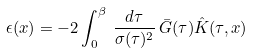<formula> <loc_0><loc_0><loc_500><loc_500>\epsilon ( x ) = - 2 \int _ { 0 } ^ { \beta } \, \frac { d \tau } { \sigma ( \tau ) ^ { 2 } } \, \bar { G } ( \tau ) \hat { K } ( \tau , x )</formula> 